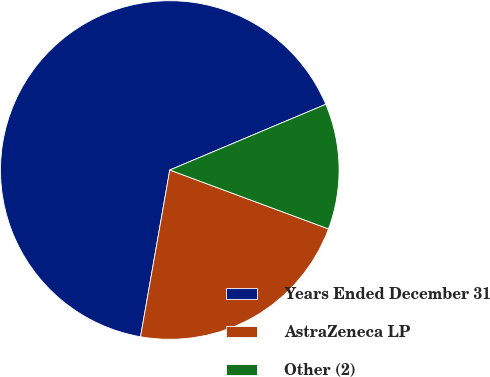<chart> <loc_0><loc_0><loc_500><loc_500><pie_chart><fcel>Years Ended December 31<fcel>AstraZeneca LP<fcel>Other (2)<nl><fcel>65.89%<fcel>22.11%<fcel>12.0%<nl></chart> 